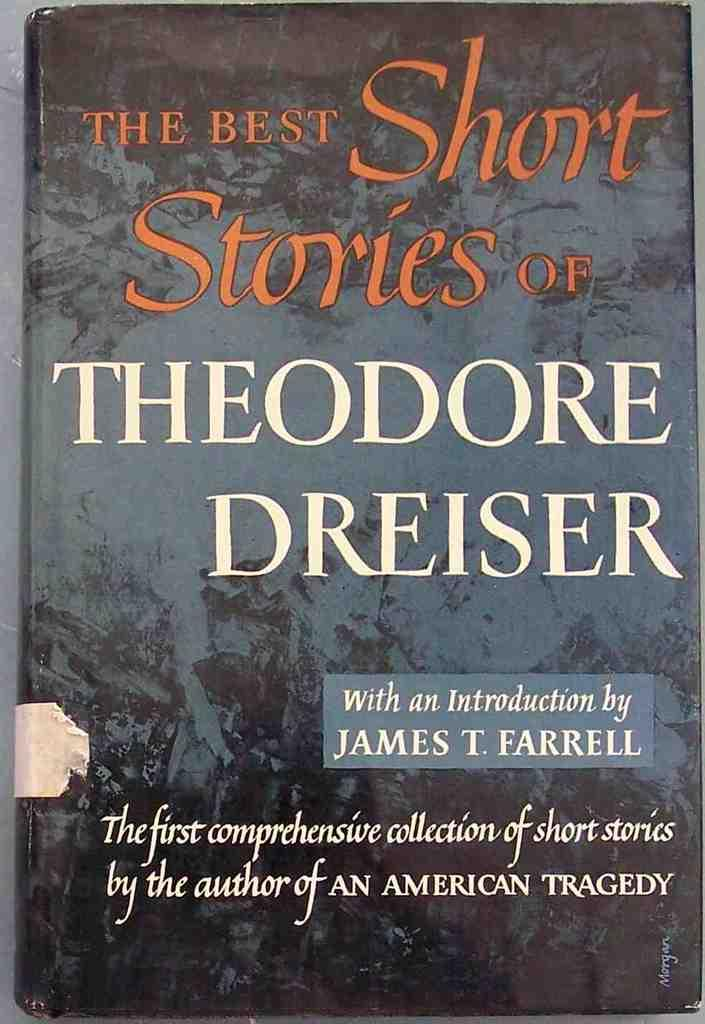<image>
Relay a brief, clear account of the picture shown. A novel by Theodore Dreiser features a grey cover. 